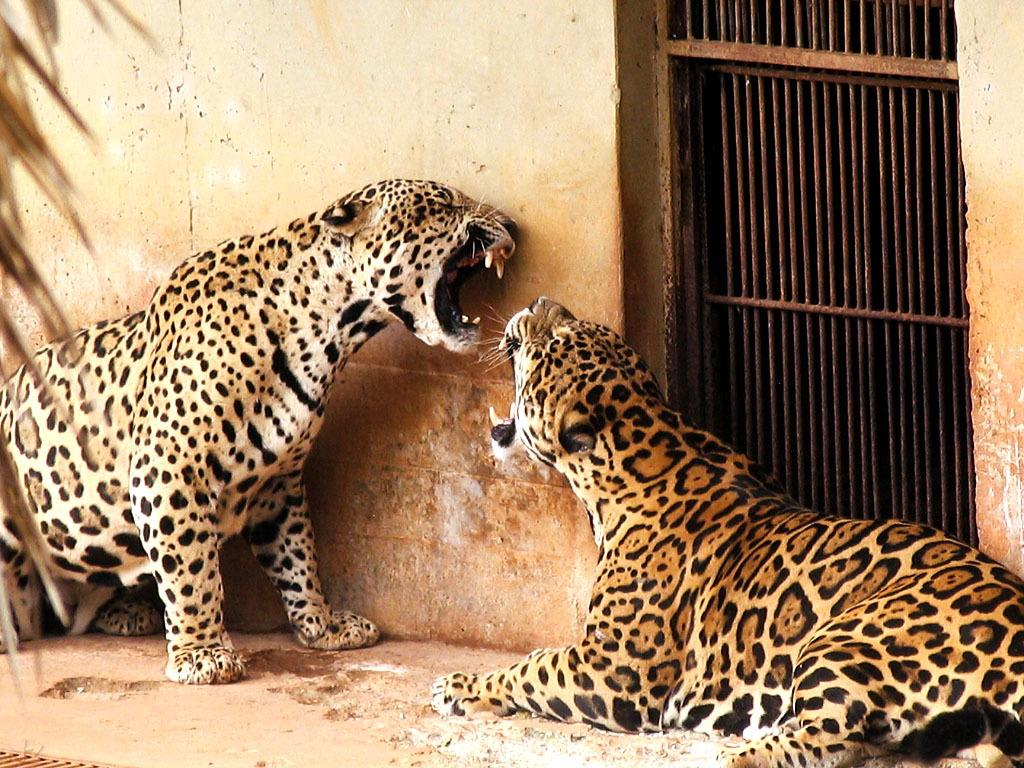What animals are located in the middle of the image? There are leopards in the middle of the image. What type of barrier is on the right side of the image? There is an iron grill on the right side of the image. What can be seen in the background of the image? There is a wall visible in the background of the image. What committee is responsible for the leopards in the image? There is no committee mentioned or implied in the image; it simply shows leopards in their natural habitat. 